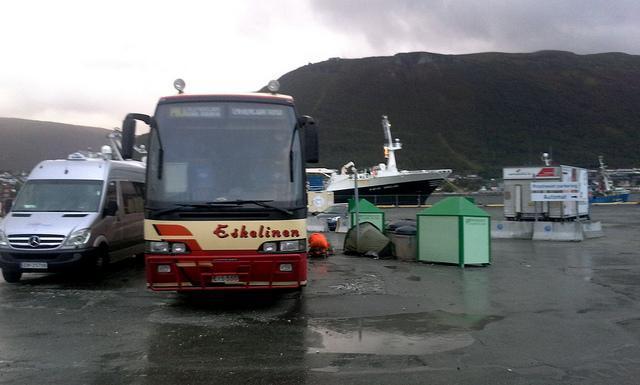What has caused the puddle in front of the bus?
Select the accurate answer and provide justification: `Answer: choice
Rationale: srationale.`
Options: Flooding, rain, snow, hose. Answer: rain.
Rationale: The gray sky and wet surface indicate precipitation, which corresponds to the term in option a. 